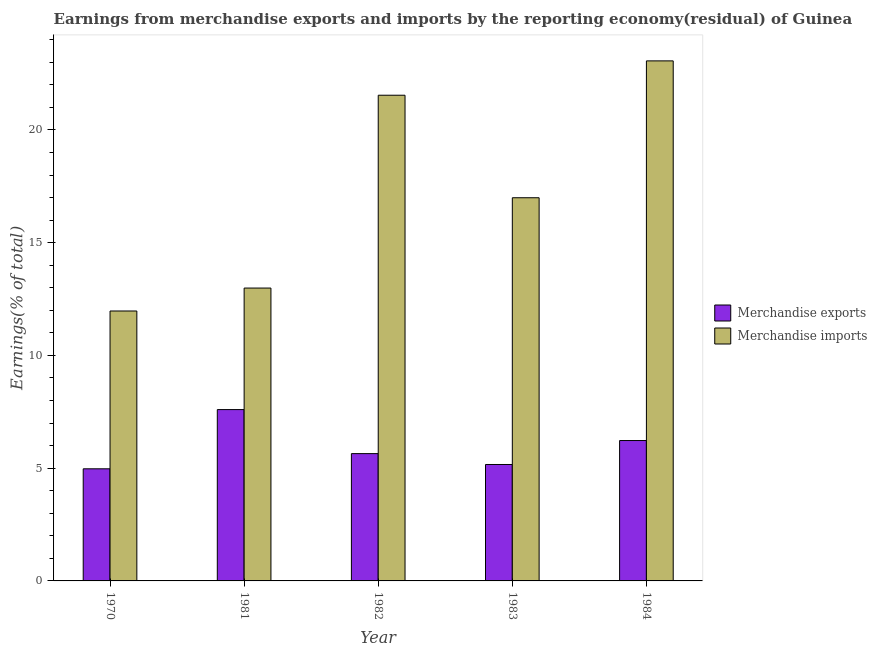Are the number of bars per tick equal to the number of legend labels?
Your response must be concise. Yes. Are the number of bars on each tick of the X-axis equal?
Your answer should be very brief. Yes. What is the label of the 3rd group of bars from the left?
Give a very brief answer. 1982. In how many cases, is the number of bars for a given year not equal to the number of legend labels?
Ensure brevity in your answer.  0. What is the earnings from merchandise imports in 1984?
Make the answer very short. 23.06. Across all years, what is the maximum earnings from merchandise exports?
Provide a short and direct response. 7.6. Across all years, what is the minimum earnings from merchandise imports?
Ensure brevity in your answer.  11.97. What is the total earnings from merchandise imports in the graph?
Ensure brevity in your answer.  86.55. What is the difference between the earnings from merchandise exports in 1970 and that in 1982?
Give a very brief answer. -0.67. What is the difference between the earnings from merchandise exports in 1984 and the earnings from merchandise imports in 1981?
Give a very brief answer. -1.37. What is the average earnings from merchandise exports per year?
Give a very brief answer. 5.92. What is the ratio of the earnings from merchandise imports in 1982 to that in 1984?
Make the answer very short. 0.93. Is the difference between the earnings from merchandise imports in 1970 and 1982 greater than the difference between the earnings from merchandise exports in 1970 and 1982?
Provide a short and direct response. No. What is the difference between the highest and the second highest earnings from merchandise imports?
Offer a very short reply. 1.52. What is the difference between the highest and the lowest earnings from merchandise exports?
Offer a very short reply. 2.63. In how many years, is the earnings from merchandise imports greater than the average earnings from merchandise imports taken over all years?
Provide a short and direct response. 2. What does the 2nd bar from the right in 1984 represents?
Keep it short and to the point. Merchandise exports. How many bars are there?
Your response must be concise. 10. How many years are there in the graph?
Your response must be concise. 5. Are the values on the major ticks of Y-axis written in scientific E-notation?
Ensure brevity in your answer.  No. Does the graph contain any zero values?
Your answer should be very brief. No. How many legend labels are there?
Provide a short and direct response. 2. How are the legend labels stacked?
Give a very brief answer. Vertical. What is the title of the graph?
Your answer should be very brief. Earnings from merchandise exports and imports by the reporting economy(residual) of Guinea. What is the label or title of the Y-axis?
Make the answer very short. Earnings(% of total). What is the Earnings(% of total) of Merchandise exports in 1970?
Ensure brevity in your answer.  4.97. What is the Earnings(% of total) in Merchandise imports in 1970?
Offer a terse response. 11.97. What is the Earnings(% of total) in Merchandise exports in 1981?
Your response must be concise. 7.6. What is the Earnings(% of total) in Merchandise imports in 1981?
Provide a succinct answer. 12.99. What is the Earnings(% of total) in Merchandise exports in 1982?
Your answer should be very brief. 5.65. What is the Earnings(% of total) of Merchandise imports in 1982?
Make the answer very short. 21.54. What is the Earnings(% of total) in Merchandise exports in 1983?
Offer a terse response. 5.16. What is the Earnings(% of total) of Merchandise imports in 1983?
Offer a terse response. 16.99. What is the Earnings(% of total) in Merchandise exports in 1984?
Make the answer very short. 6.23. What is the Earnings(% of total) of Merchandise imports in 1984?
Your answer should be compact. 23.06. Across all years, what is the maximum Earnings(% of total) in Merchandise exports?
Provide a short and direct response. 7.6. Across all years, what is the maximum Earnings(% of total) of Merchandise imports?
Your answer should be very brief. 23.06. Across all years, what is the minimum Earnings(% of total) in Merchandise exports?
Give a very brief answer. 4.97. Across all years, what is the minimum Earnings(% of total) of Merchandise imports?
Make the answer very short. 11.97. What is the total Earnings(% of total) of Merchandise exports in the graph?
Offer a very short reply. 29.6. What is the total Earnings(% of total) in Merchandise imports in the graph?
Your answer should be very brief. 86.55. What is the difference between the Earnings(% of total) of Merchandise exports in 1970 and that in 1981?
Your answer should be very brief. -2.63. What is the difference between the Earnings(% of total) of Merchandise imports in 1970 and that in 1981?
Keep it short and to the point. -1.02. What is the difference between the Earnings(% of total) in Merchandise exports in 1970 and that in 1982?
Offer a very short reply. -0.67. What is the difference between the Earnings(% of total) of Merchandise imports in 1970 and that in 1982?
Your answer should be compact. -9.57. What is the difference between the Earnings(% of total) in Merchandise exports in 1970 and that in 1983?
Give a very brief answer. -0.19. What is the difference between the Earnings(% of total) of Merchandise imports in 1970 and that in 1983?
Make the answer very short. -5.02. What is the difference between the Earnings(% of total) of Merchandise exports in 1970 and that in 1984?
Your answer should be very brief. -1.25. What is the difference between the Earnings(% of total) of Merchandise imports in 1970 and that in 1984?
Provide a short and direct response. -11.09. What is the difference between the Earnings(% of total) in Merchandise exports in 1981 and that in 1982?
Your answer should be very brief. 1.95. What is the difference between the Earnings(% of total) of Merchandise imports in 1981 and that in 1982?
Offer a terse response. -8.55. What is the difference between the Earnings(% of total) of Merchandise exports in 1981 and that in 1983?
Your answer should be very brief. 2.43. What is the difference between the Earnings(% of total) in Merchandise imports in 1981 and that in 1983?
Your answer should be very brief. -4.01. What is the difference between the Earnings(% of total) in Merchandise exports in 1981 and that in 1984?
Offer a very short reply. 1.37. What is the difference between the Earnings(% of total) in Merchandise imports in 1981 and that in 1984?
Provide a succinct answer. -10.07. What is the difference between the Earnings(% of total) of Merchandise exports in 1982 and that in 1983?
Ensure brevity in your answer.  0.48. What is the difference between the Earnings(% of total) of Merchandise imports in 1982 and that in 1983?
Your answer should be compact. 4.55. What is the difference between the Earnings(% of total) of Merchandise exports in 1982 and that in 1984?
Your answer should be compact. -0.58. What is the difference between the Earnings(% of total) of Merchandise imports in 1982 and that in 1984?
Offer a very short reply. -1.52. What is the difference between the Earnings(% of total) in Merchandise exports in 1983 and that in 1984?
Provide a short and direct response. -1.06. What is the difference between the Earnings(% of total) of Merchandise imports in 1983 and that in 1984?
Provide a short and direct response. -6.07. What is the difference between the Earnings(% of total) in Merchandise exports in 1970 and the Earnings(% of total) in Merchandise imports in 1981?
Make the answer very short. -8.01. What is the difference between the Earnings(% of total) of Merchandise exports in 1970 and the Earnings(% of total) of Merchandise imports in 1982?
Your answer should be compact. -16.57. What is the difference between the Earnings(% of total) of Merchandise exports in 1970 and the Earnings(% of total) of Merchandise imports in 1983?
Your response must be concise. -12.02. What is the difference between the Earnings(% of total) of Merchandise exports in 1970 and the Earnings(% of total) of Merchandise imports in 1984?
Ensure brevity in your answer.  -18.09. What is the difference between the Earnings(% of total) in Merchandise exports in 1981 and the Earnings(% of total) in Merchandise imports in 1982?
Provide a short and direct response. -13.94. What is the difference between the Earnings(% of total) of Merchandise exports in 1981 and the Earnings(% of total) of Merchandise imports in 1983?
Your answer should be compact. -9.39. What is the difference between the Earnings(% of total) of Merchandise exports in 1981 and the Earnings(% of total) of Merchandise imports in 1984?
Keep it short and to the point. -15.46. What is the difference between the Earnings(% of total) of Merchandise exports in 1982 and the Earnings(% of total) of Merchandise imports in 1983?
Keep it short and to the point. -11.35. What is the difference between the Earnings(% of total) in Merchandise exports in 1982 and the Earnings(% of total) in Merchandise imports in 1984?
Provide a succinct answer. -17.42. What is the difference between the Earnings(% of total) of Merchandise exports in 1983 and the Earnings(% of total) of Merchandise imports in 1984?
Offer a very short reply. -17.9. What is the average Earnings(% of total) in Merchandise exports per year?
Ensure brevity in your answer.  5.92. What is the average Earnings(% of total) of Merchandise imports per year?
Keep it short and to the point. 17.31. In the year 1970, what is the difference between the Earnings(% of total) of Merchandise exports and Earnings(% of total) of Merchandise imports?
Provide a short and direct response. -7. In the year 1981, what is the difference between the Earnings(% of total) of Merchandise exports and Earnings(% of total) of Merchandise imports?
Keep it short and to the point. -5.39. In the year 1982, what is the difference between the Earnings(% of total) of Merchandise exports and Earnings(% of total) of Merchandise imports?
Your response must be concise. -15.89. In the year 1983, what is the difference between the Earnings(% of total) of Merchandise exports and Earnings(% of total) of Merchandise imports?
Provide a short and direct response. -11.83. In the year 1984, what is the difference between the Earnings(% of total) of Merchandise exports and Earnings(% of total) of Merchandise imports?
Offer a very short reply. -16.84. What is the ratio of the Earnings(% of total) of Merchandise exports in 1970 to that in 1981?
Make the answer very short. 0.65. What is the ratio of the Earnings(% of total) of Merchandise imports in 1970 to that in 1981?
Your response must be concise. 0.92. What is the ratio of the Earnings(% of total) of Merchandise exports in 1970 to that in 1982?
Your response must be concise. 0.88. What is the ratio of the Earnings(% of total) of Merchandise imports in 1970 to that in 1982?
Your answer should be very brief. 0.56. What is the ratio of the Earnings(% of total) of Merchandise imports in 1970 to that in 1983?
Your response must be concise. 0.7. What is the ratio of the Earnings(% of total) in Merchandise exports in 1970 to that in 1984?
Ensure brevity in your answer.  0.8. What is the ratio of the Earnings(% of total) in Merchandise imports in 1970 to that in 1984?
Give a very brief answer. 0.52. What is the ratio of the Earnings(% of total) of Merchandise exports in 1981 to that in 1982?
Ensure brevity in your answer.  1.35. What is the ratio of the Earnings(% of total) of Merchandise imports in 1981 to that in 1982?
Provide a succinct answer. 0.6. What is the ratio of the Earnings(% of total) of Merchandise exports in 1981 to that in 1983?
Keep it short and to the point. 1.47. What is the ratio of the Earnings(% of total) of Merchandise imports in 1981 to that in 1983?
Provide a short and direct response. 0.76. What is the ratio of the Earnings(% of total) in Merchandise exports in 1981 to that in 1984?
Your answer should be compact. 1.22. What is the ratio of the Earnings(% of total) in Merchandise imports in 1981 to that in 1984?
Provide a succinct answer. 0.56. What is the ratio of the Earnings(% of total) in Merchandise exports in 1982 to that in 1983?
Provide a succinct answer. 1.09. What is the ratio of the Earnings(% of total) in Merchandise imports in 1982 to that in 1983?
Offer a terse response. 1.27. What is the ratio of the Earnings(% of total) of Merchandise exports in 1982 to that in 1984?
Your response must be concise. 0.91. What is the ratio of the Earnings(% of total) in Merchandise imports in 1982 to that in 1984?
Give a very brief answer. 0.93. What is the ratio of the Earnings(% of total) in Merchandise exports in 1983 to that in 1984?
Your answer should be compact. 0.83. What is the ratio of the Earnings(% of total) of Merchandise imports in 1983 to that in 1984?
Offer a terse response. 0.74. What is the difference between the highest and the second highest Earnings(% of total) in Merchandise exports?
Offer a very short reply. 1.37. What is the difference between the highest and the second highest Earnings(% of total) of Merchandise imports?
Ensure brevity in your answer.  1.52. What is the difference between the highest and the lowest Earnings(% of total) of Merchandise exports?
Offer a very short reply. 2.63. What is the difference between the highest and the lowest Earnings(% of total) in Merchandise imports?
Provide a short and direct response. 11.09. 